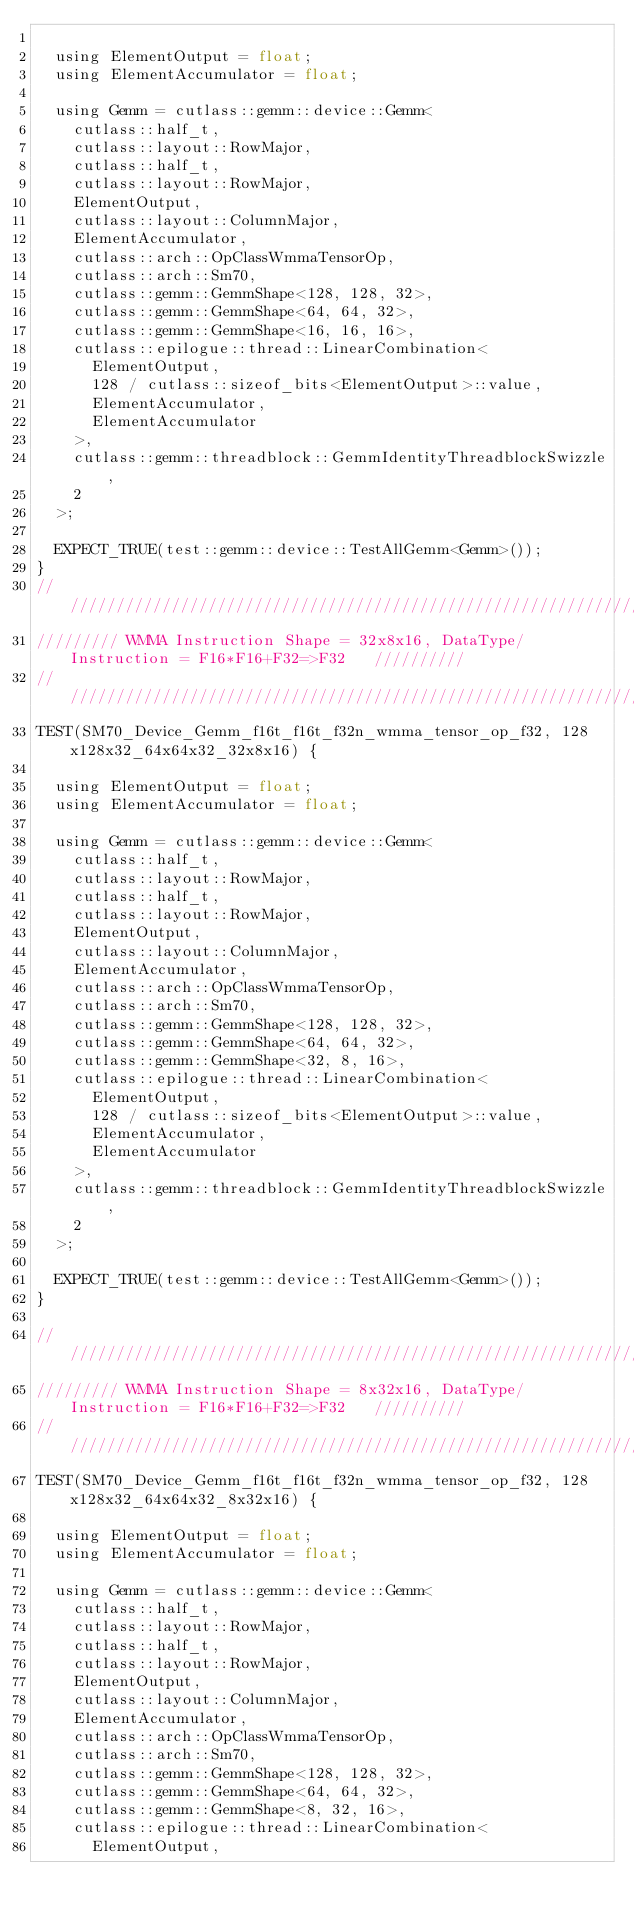Convert code to text. <code><loc_0><loc_0><loc_500><loc_500><_Cuda_>
  using ElementOutput = float;
  using ElementAccumulator = float;

  using Gemm = cutlass::gemm::device::Gemm<
    cutlass::half_t,
    cutlass::layout::RowMajor,
    cutlass::half_t,
    cutlass::layout::RowMajor,
    ElementOutput,
    cutlass::layout::ColumnMajor,
    ElementAccumulator,
    cutlass::arch::OpClassWmmaTensorOp,
    cutlass::arch::Sm70,
    cutlass::gemm::GemmShape<128, 128, 32>,
    cutlass::gemm::GemmShape<64, 64, 32>,
    cutlass::gemm::GemmShape<16, 16, 16>,
    cutlass::epilogue::thread::LinearCombination<
      ElementOutput,
      128 / cutlass::sizeof_bits<ElementOutput>::value,
      ElementAccumulator,
      ElementAccumulator
    >,
    cutlass::gemm::threadblock::GemmIdentityThreadblockSwizzle,
    2
  >;

  EXPECT_TRUE(test::gemm::device::TestAllGemm<Gemm>());
}
/////////////////////////////////////////////////////////////////////////////////////////////////
///////// WMMA Instruction Shape = 32x8x16, DataType/Instruction = F16*F16+F32=>F32   //////////
/////////////////////////////////////////////////////////////////////////////////////////////////  
TEST(SM70_Device_Gemm_f16t_f16t_f32n_wmma_tensor_op_f32, 128x128x32_64x64x32_32x8x16) {

  using ElementOutput = float;
  using ElementAccumulator = float;

  using Gemm = cutlass::gemm::device::Gemm<
    cutlass::half_t,
    cutlass::layout::RowMajor,
    cutlass::half_t,
    cutlass::layout::RowMajor,
    ElementOutput,
    cutlass::layout::ColumnMajor,
    ElementAccumulator,
    cutlass::arch::OpClassWmmaTensorOp,
    cutlass::arch::Sm70,
    cutlass::gemm::GemmShape<128, 128, 32>,
    cutlass::gemm::GemmShape<64, 64, 32>,
    cutlass::gemm::GemmShape<32, 8, 16>,
    cutlass::epilogue::thread::LinearCombination<
      ElementOutput,
      128 / cutlass::sizeof_bits<ElementOutput>::value,
      ElementAccumulator,
      ElementAccumulator
    >,
    cutlass::gemm::threadblock::GemmIdentityThreadblockSwizzle,
    2
  >;

  EXPECT_TRUE(test::gemm::device::TestAllGemm<Gemm>());
}

/////////////////////////////////////////////////////////////////////////////////////////////////
///////// WMMA Instruction Shape = 8x32x16, DataType/Instruction = F16*F16+F32=>F32   //////////
/////////////////////////////////////////////////////////////////////////////////////////////////  
TEST(SM70_Device_Gemm_f16t_f16t_f32n_wmma_tensor_op_f32, 128x128x32_64x64x32_8x32x16) {

  using ElementOutput = float;
  using ElementAccumulator = float;

  using Gemm = cutlass::gemm::device::Gemm<
    cutlass::half_t,
    cutlass::layout::RowMajor,
    cutlass::half_t,
    cutlass::layout::RowMajor,
    ElementOutput,
    cutlass::layout::ColumnMajor,
    ElementAccumulator,
    cutlass::arch::OpClassWmmaTensorOp,
    cutlass::arch::Sm70,
    cutlass::gemm::GemmShape<128, 128, 32>,
    cutlass::gemm::GemmShape<64, 64, 32>,
    cutlass::gemm::GemmShape<8, 32, 16>,
    cutlass::epilogue::thread::LinearCombination<
      ElementOutput,</code> 